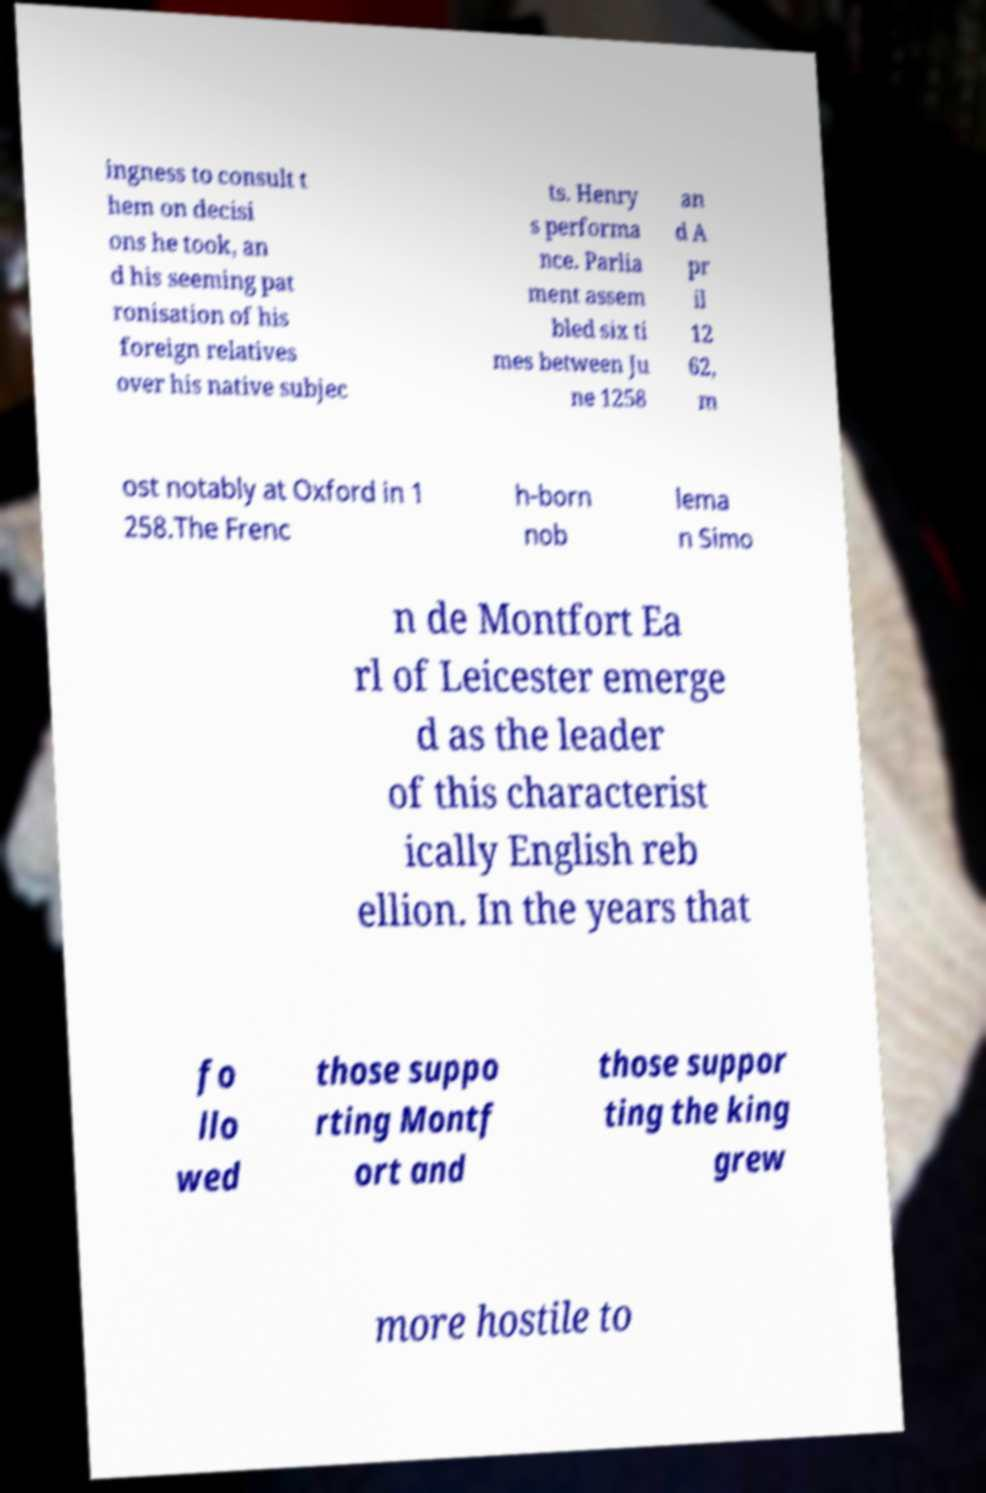There's text embedded in this image that I need extracted. Can you transcribe it verbatim? ingness to consult t hem on decisi ons he took, an d his seeming pat ronisation of his foreign relatives over his native subjec ts. Henry s performa nce. Parlia ment assem bled six ti mes between Ju ne 1258 an d A pr il 12 62, m ost notably at Oxford in 1 258.The Frenc h-born nob lema n Simo n de Montfort Ea rl of Leicester emerge d as the leader of this characterist ically English reb ellion. In the years that fo llo wed those suppo rting Montf ort and those suppor ting the king grew more hostile to 